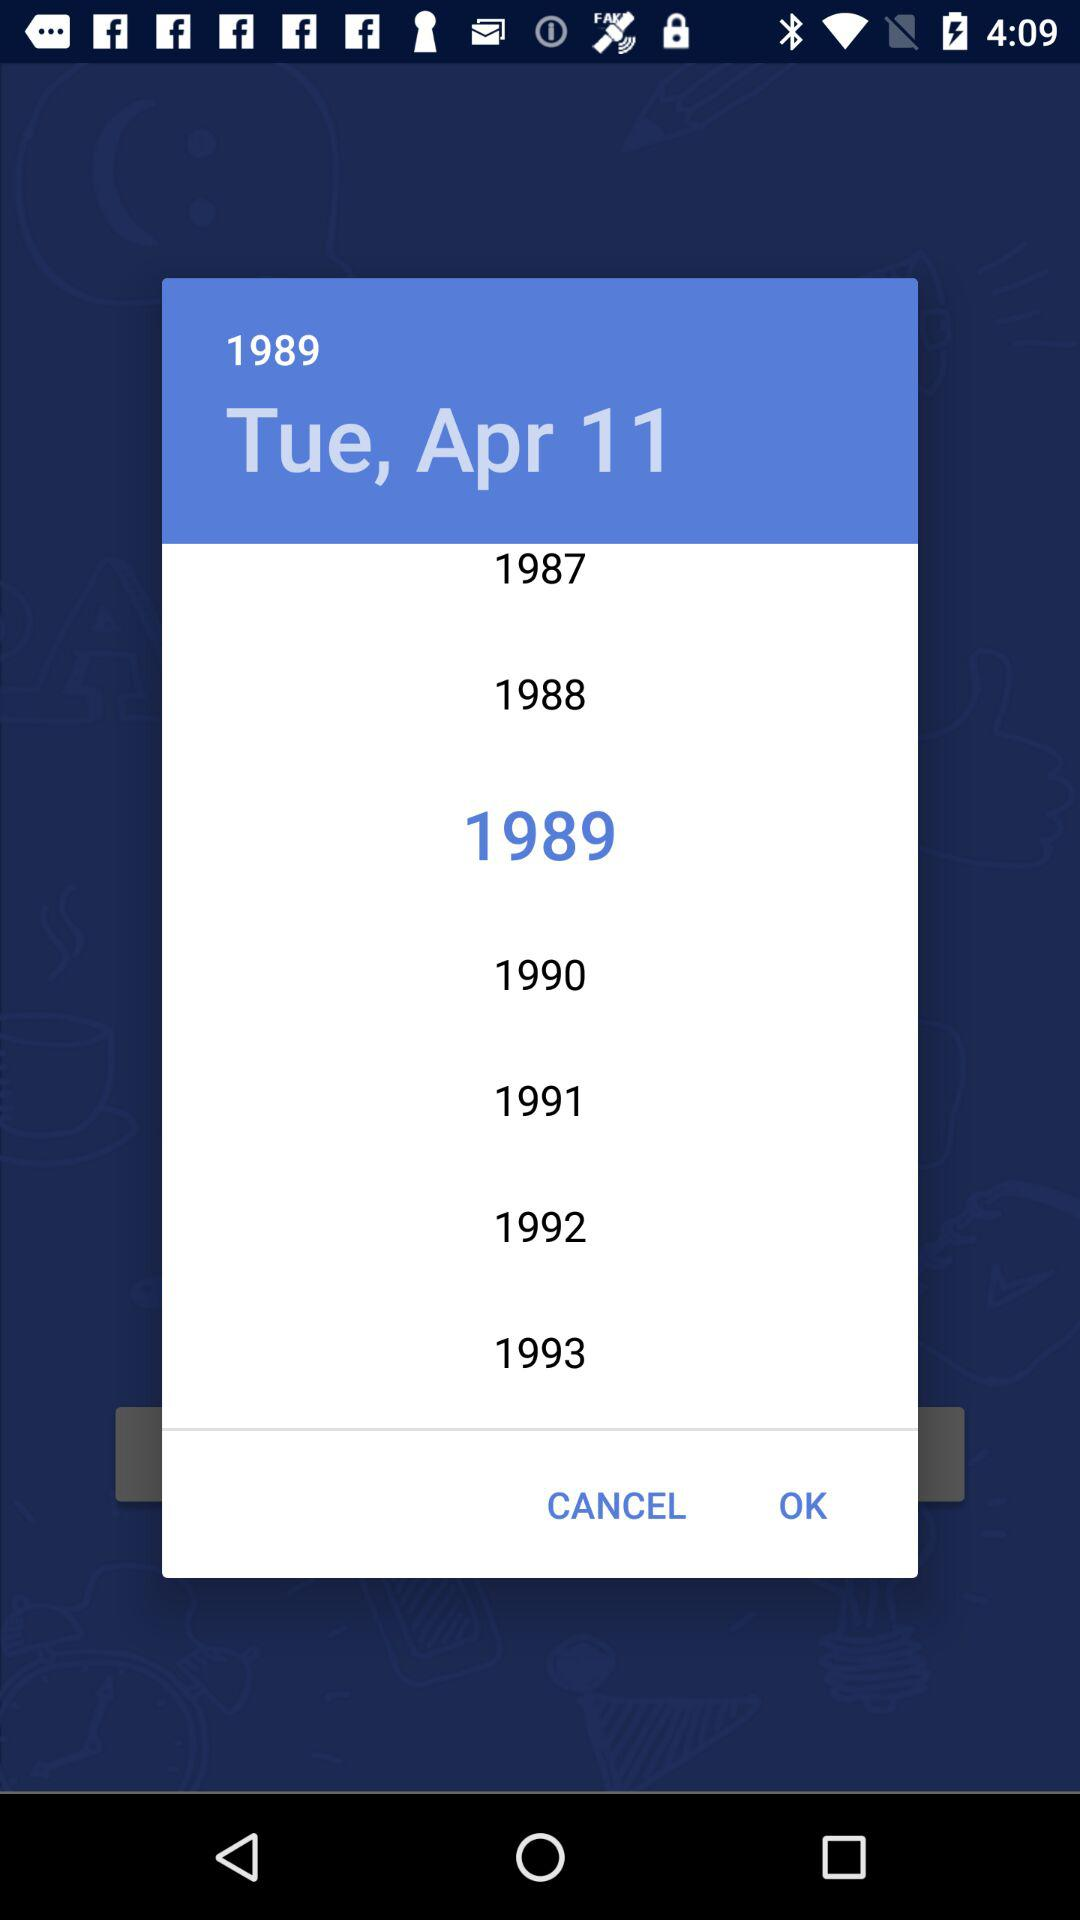Which day is displayed on the screen? The day is Tuesday. 